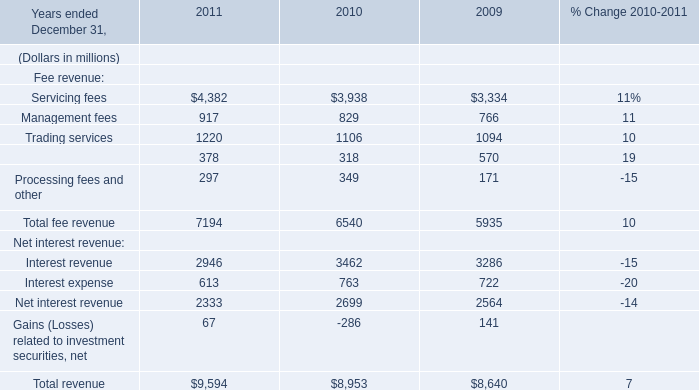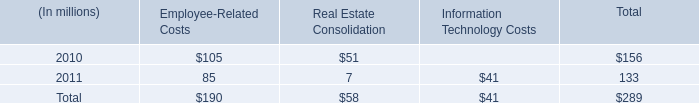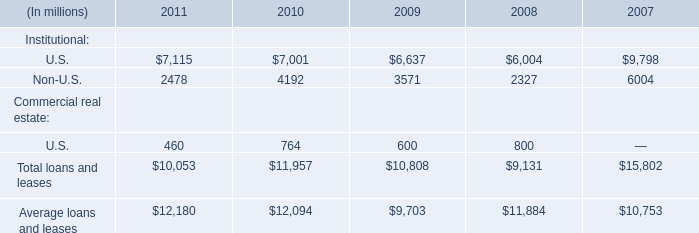What will securities finance reach in 2011 if it continues to grow at its current rate? (in million) 
Computations: ((((378 - 318) / 318) + 1) * 378)
Answer: 449.32075. 